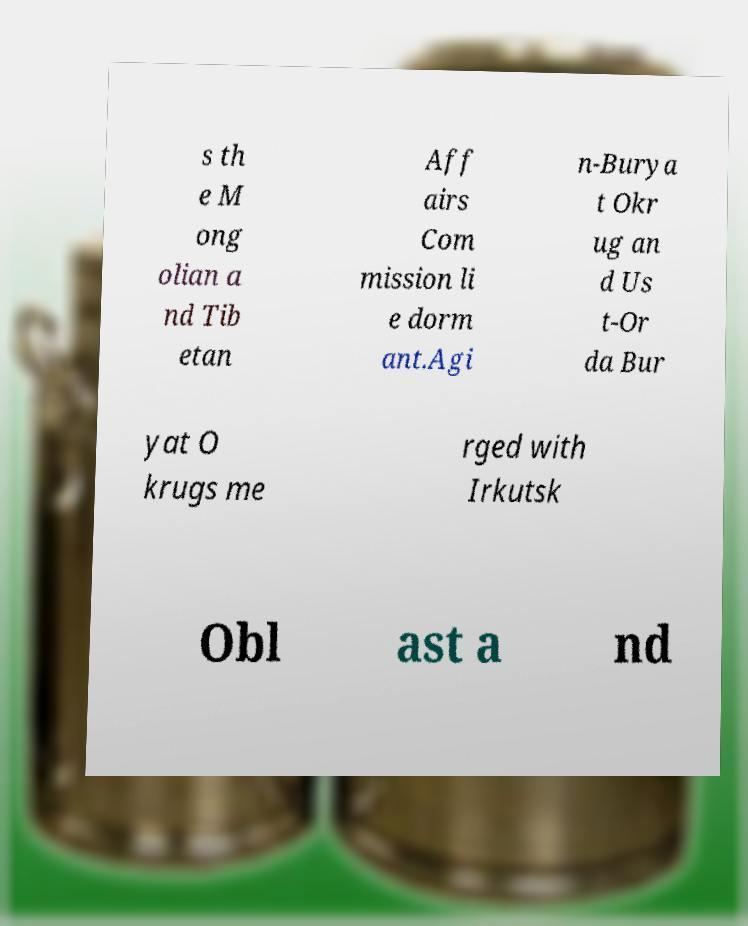Can you accurately transcribe the text from the provided image for me? s th e M ong olian a nd Tib etan Aff airs Com mission li e dorm ant.Agi n-Burya t Okr ug an d Us t-Or da Bur yat O krugs me rged with Irkutsk Obl ast a nd 